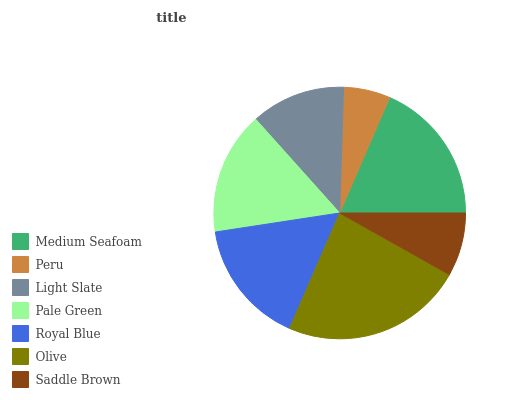Is Peru the minimum?
Answer yes or no. Yes. Is Olive the maximum?
Answer yes or no. Yes. Is Light Slate the minimum?
Answer yes or no. No. Is Light Slate the maximum?
Answer yes or no. No. Is Light Slate greater than Peru?
Answer yes or no. Yes. Is Peru less than Light Slate?
Answer yes or no. Yes. Is Peru greater than Light Slate?
Answer yes or no. No. Is Light Slate less than Peru?
Answer yes or no. No. Is Pale Green the high median?
Answer yes or no. Yes. Is Pale Green the low median?
Answer yes or no. Yes. Is Peru the high median?
Answer yes or no. No. Is Saddle Brown the low median?
Answer yes or no. No. 